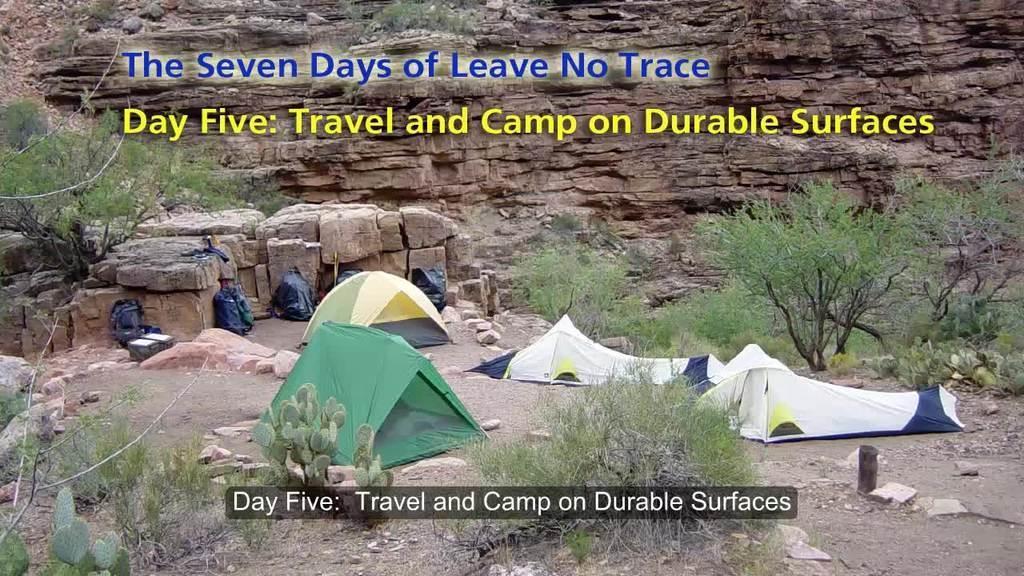In one or two sentences, can you explain what this image depicts? This picture is clicked outside. In the foreground we can see the grass, plants, rocks, tents and bags, we can see some other objects. In the background we can see the rocks and we can see the text on the image. 